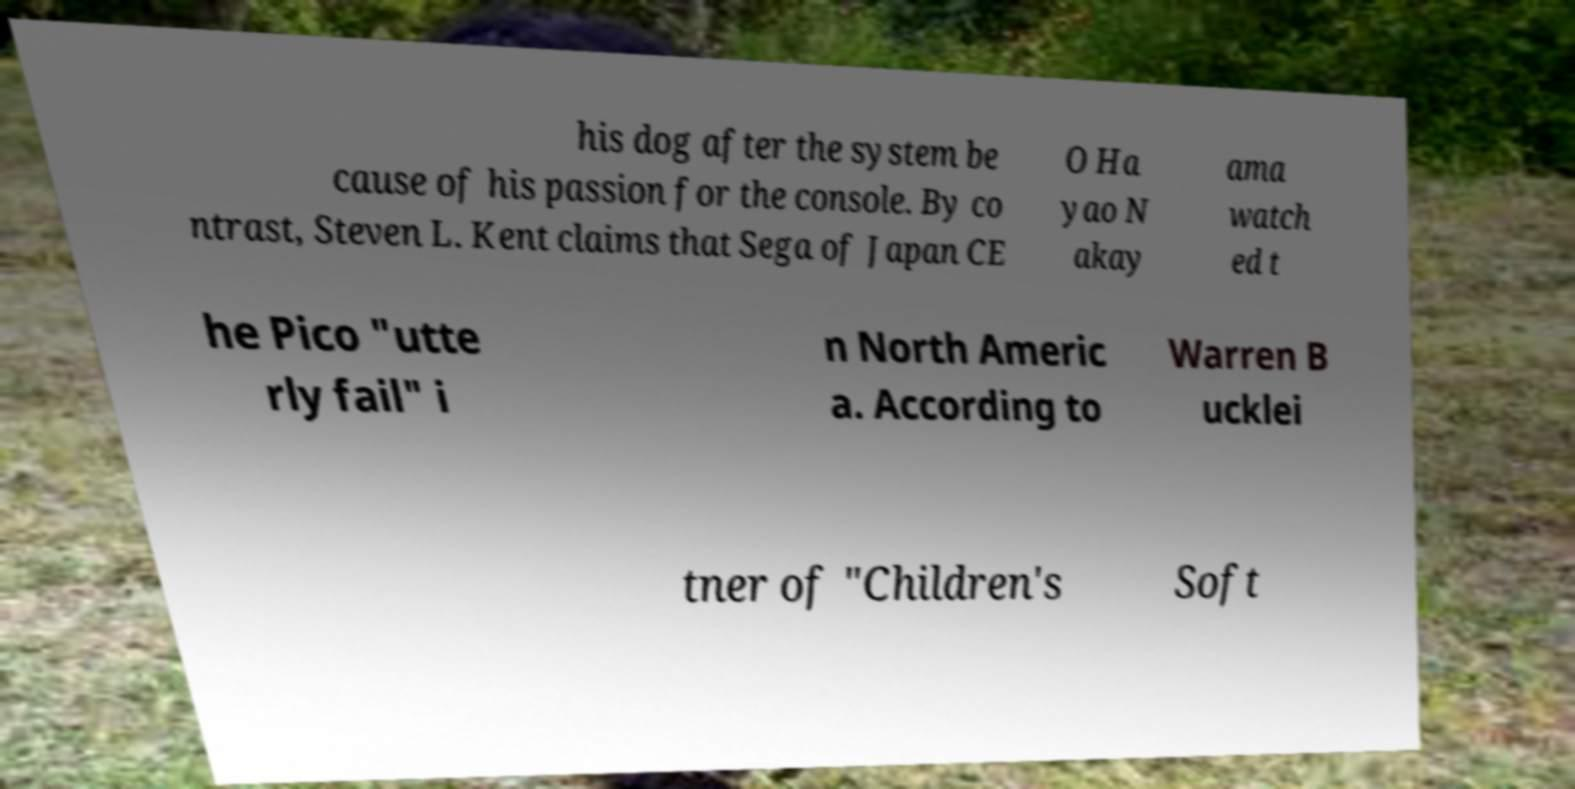Can you read and provide the text displayed in the image?This photo seems to have some interesting text. Can you extract and type it out for me? his dog after the system be cause of his passion for the console. By co ntrast, Steven L. Kent claims that Sega of Japan CE O Ha yao N akay ama watch ed t he Pico "utte rly fail" i n North Americ a. According to Warren B ucklei tner of "Children's Soft 